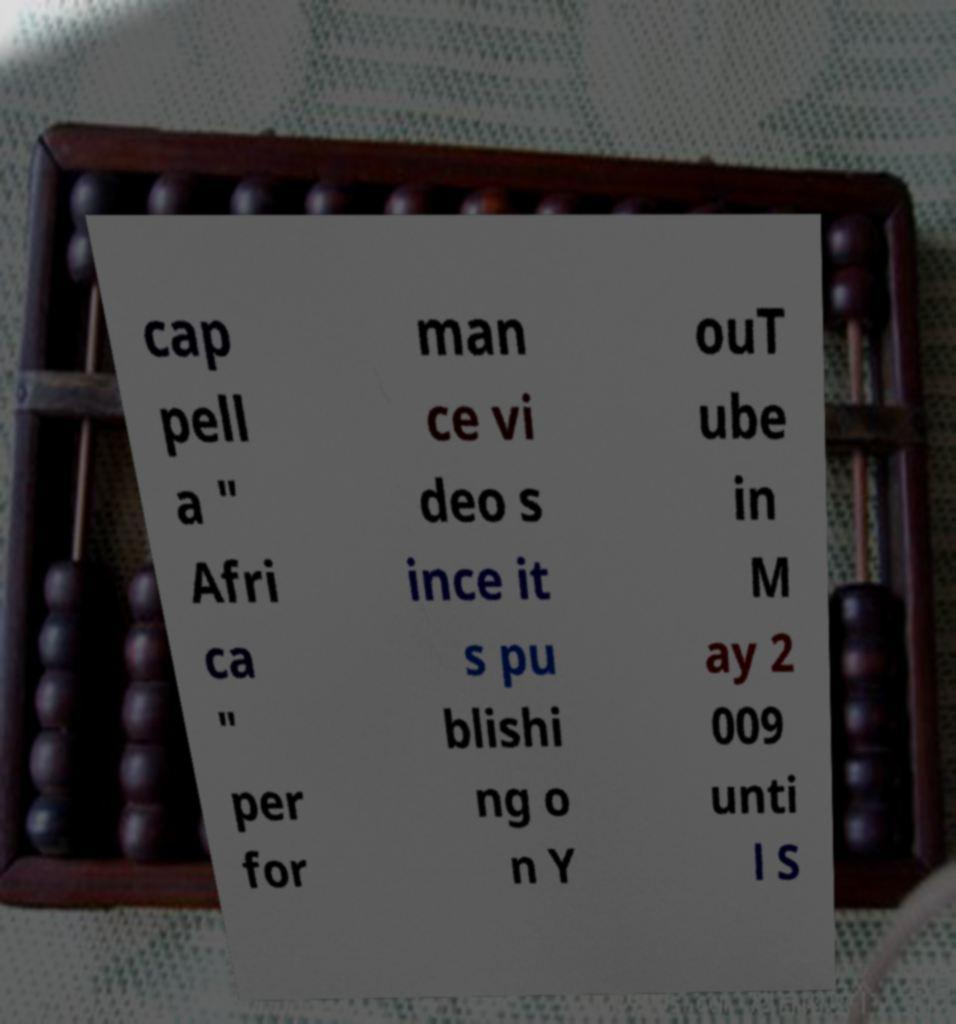Could you assist in decoding the text presented in this image and type it out clearly? cap pell a " Afri ca " per for man ce vi deo s ince it s pu blishi ng o n Y ouT ube in M ay 2 009 unti l S 